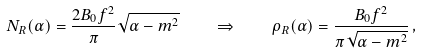Convert formula to latex. <formula><loc_0><loc_0><loc_500><loc_500>N _ { R } ( \alpha ) = \frac { 2 B _ { 0 } f ^ { 2 } } { \pi } \sqrt { \alpha - m ^ { 2 } } \quad \Rightarrow \quad \rho _ { R } ( \alpha ) = \frac { B _ { 0 } f ^ { 2 } } { \pi \sqrt { \alpha - m ^ { 2 } } } \, ,</formula> 